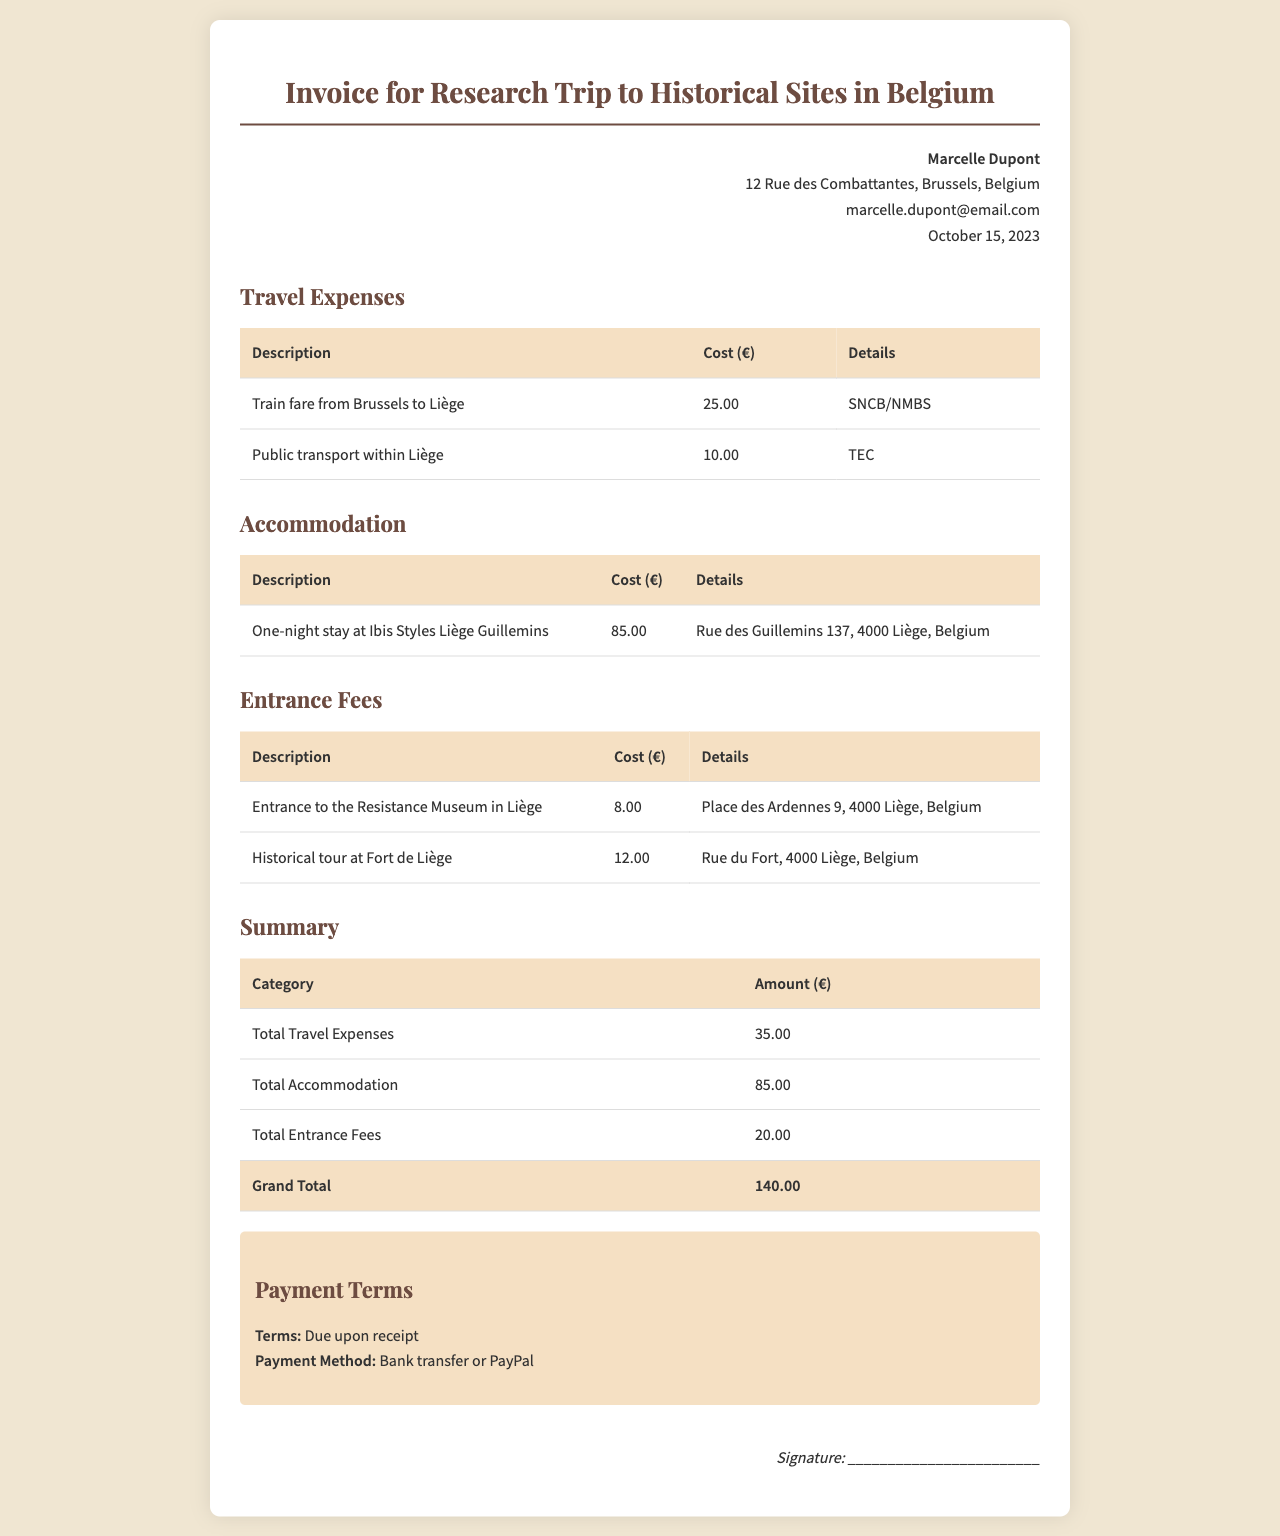What is the total cost for travel expenses? The total travel expenses are found in the summary table, which lists them as €35.00.
Answer: €35.00 What date is the invoice dated? The invoice date is stated in the header information, which shows October 15, 2023.
Answer: October 15, 2023 How much did the one-night stay cost? The accommodation section lists the one-night stay at Ibis Styles Liège Guillemins for €85.00.
Answer: €85.00 What is the grand total for the invoice? The grand total is the sum of all expenses listed in the summary table, which adds up to €140.00.
Answer: €140.00 What public transport did Marcelle use in Liège? The travel expenses specifically mention public transport within Liège as €10.00 under TEC.
Answer: TEC What is the address of the Resistance Museum in Liège? The entrance fees section provides the address as Place des Ardennes 9, 4000 Liège, Belgium.
Answer: Place des Ardennes 9, 4000 Liège, Belgium What payment method is accepted for this invoice? The payment terms section mentions bank transfer or PayPal as the payment methods.
Answer: Bank transfer or PayPal How many total entrance fees are listed in the invoice? The entrance fees section lists two specific fees: one for the Resistance Museum and another for the Fort de Liège.
Answer: Two 